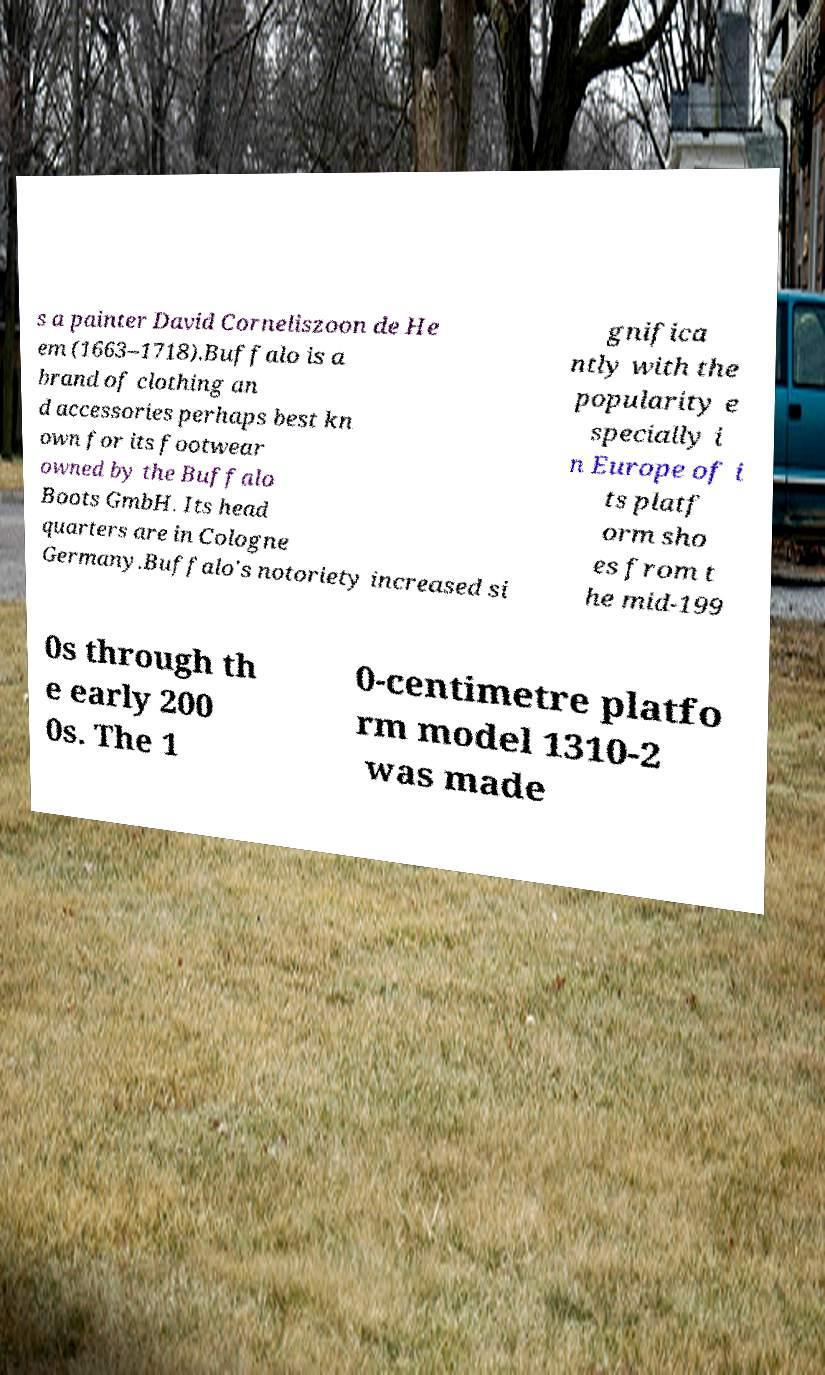Could you extract and type out the text from this image? s a painter David Corneliszoon de He em (1663–1718).Buffalo is a brand of clothing an d accessories perhaps best kn own for its footwear owned by the Buffalo Boots GmbH. Its head quarters are in Cologne Germany.Buffalo's notoriety increased si gnifica ntly with the popularity e specially i n Europe of i ts platf orm sho es from t he mid-199 0s through th e early 200 0s. The 1 0-centimetre platfo rm model 1310-2 was made 